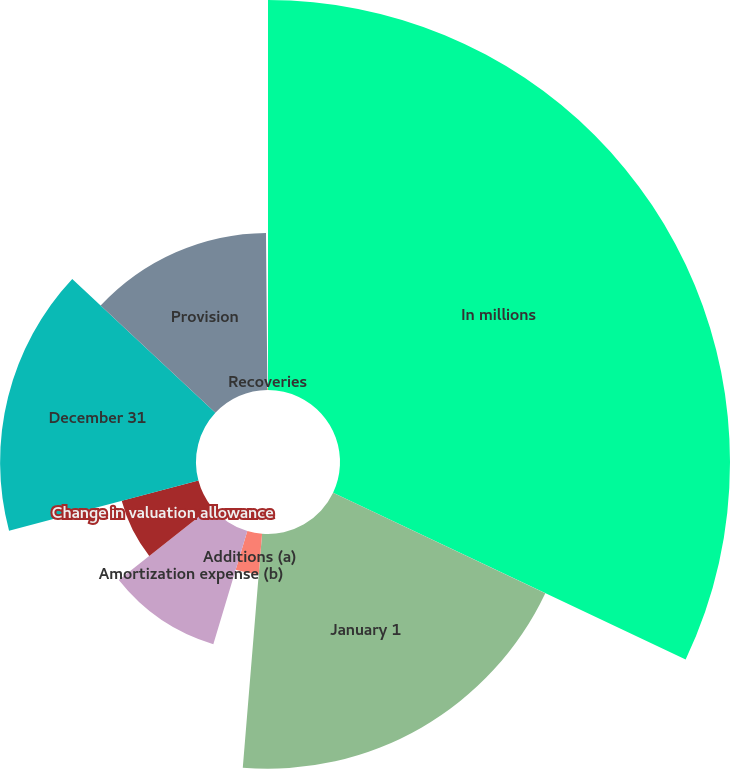<chart> <loc_0><loc_0><loc_500><loc_500><pie_chart><fcel>In millions<fcel>January 1<fcel>Additions (a)<fcel>Amortization expense (b)<fcel>Change in valuation allowance<fcel>December 31<fcel>Provision<fcel>Recoveries<nl><fcel>32.03%<fcel>19.28%<fcel>3.33%<fcel>9.71%<fcel>6.52%<fcel>16.09%<fcel>12.9%<fcel>0.14%<nl></chart> 